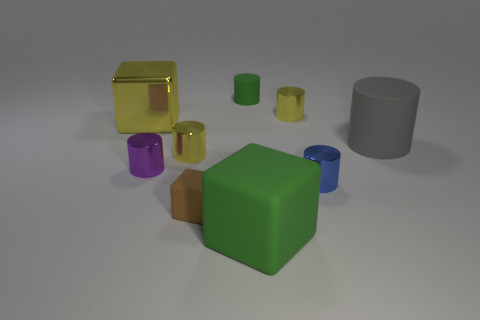What material is the large object that is the same color as the small matte cylinder?
Your answer should be compact. Rubber. There is a green matte object that is behind the big green rubber thing; does it have the same shape as the small yellow thing that is to the right of the small green matte object?
Your answer should be very brief. Yes. How many other objects are there of the same color as the big shiny object?
Provide a short and direct response. 2. Do the small purple object and the large object in front of the tiny brown rubber cube have the same material?
Provide a short and direct response. No. Is the small blue cylinder made of the same material as the tiny purple object?
Give a very brief answer. Yes. There is a metallic cylinder behind the big yellow shiny object; is there a big yellow metal thing that is right of it?
Keep it short and to the point. No. What number of green matte things are to the left of the big rubber cube and in front of the small blue cylinder?
Ensure brevity in your answer.  0. There is a big thing to the right of the blue metal cylinder; what is its shape?
Give a very brief answer. Cylinder. What number of purple cylinders are the same size as the brown cube?
Give a very brief answer. 1. There is a metallic cylinder behind the gray matte thing; does it have the same color as the big metal cube?
Ensure brevity in your answer.  Yes. 